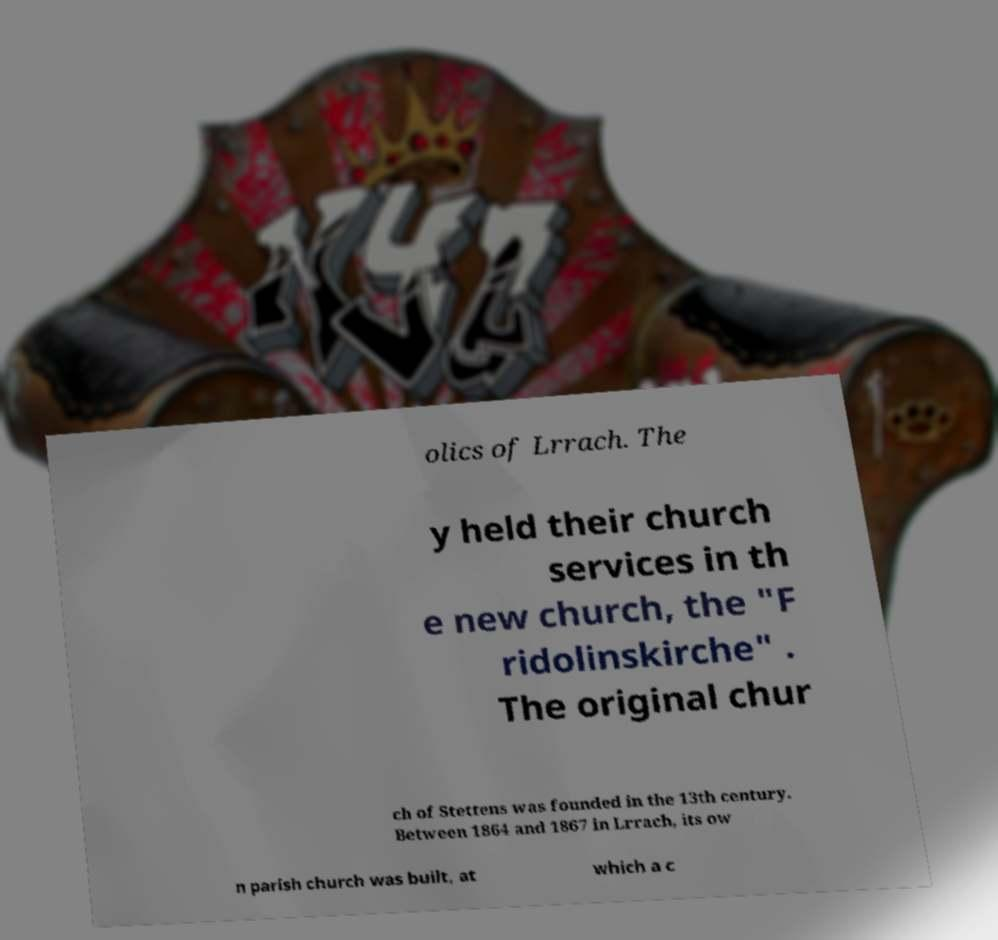There's text embedded in this image that I need extracted. Can you transcribe it verbatim? olics of Lrrach. The y held their church services in th e new church, the "F ridolinskirche" . The original chur ch of Stettens was founded in the 13th century. Between 1864 and 1867 in Lrrach, its ow n parish church was built, at which a c 